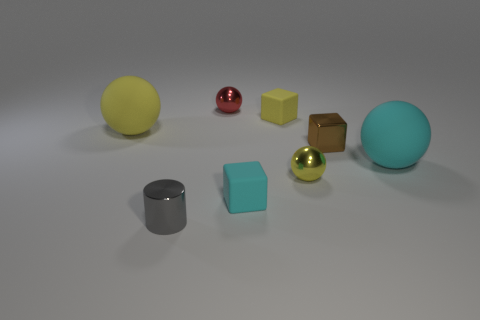There is a small object that is both to the left of the cyan rubber cube and behind the gray cylinder; what is its color?
Offer a very short reply. Red. What number of tiny shiny things are in front of the large rubber object on the left side of the tiny gray metallic cylinder?
Ensure brevity in your answer.  3. What material is the cyan thing that is the same shape as the tiny brown thing?
Give a very brief answer. Rubber. What is the color of the cylinder?
Your answer should be compact. Gray. How many things are either shiny cylinders or large cyan matte things?
Make the answer very short. 2. There is a large rubber object that is left of the rubber ball that is right of the tiny brown metal cube; what shape is it?
Your answer should be very brief. Sphere. What number of other objects are the same material as the large yellow thing?
Provide a succinct answer. 3. Are the tiny brown thing and the yellow ball on the right side of the large yellow rubber thing made of the same material?
Offer a very short reply. Yes. How many objects are either large things that are right of the tiny gray cylinder or objects in front of the red metal thing?
Offer a very short reply. 7. How many other things are there of the same color as the small cylinder?
Ensure brevity in your answer.  0. 